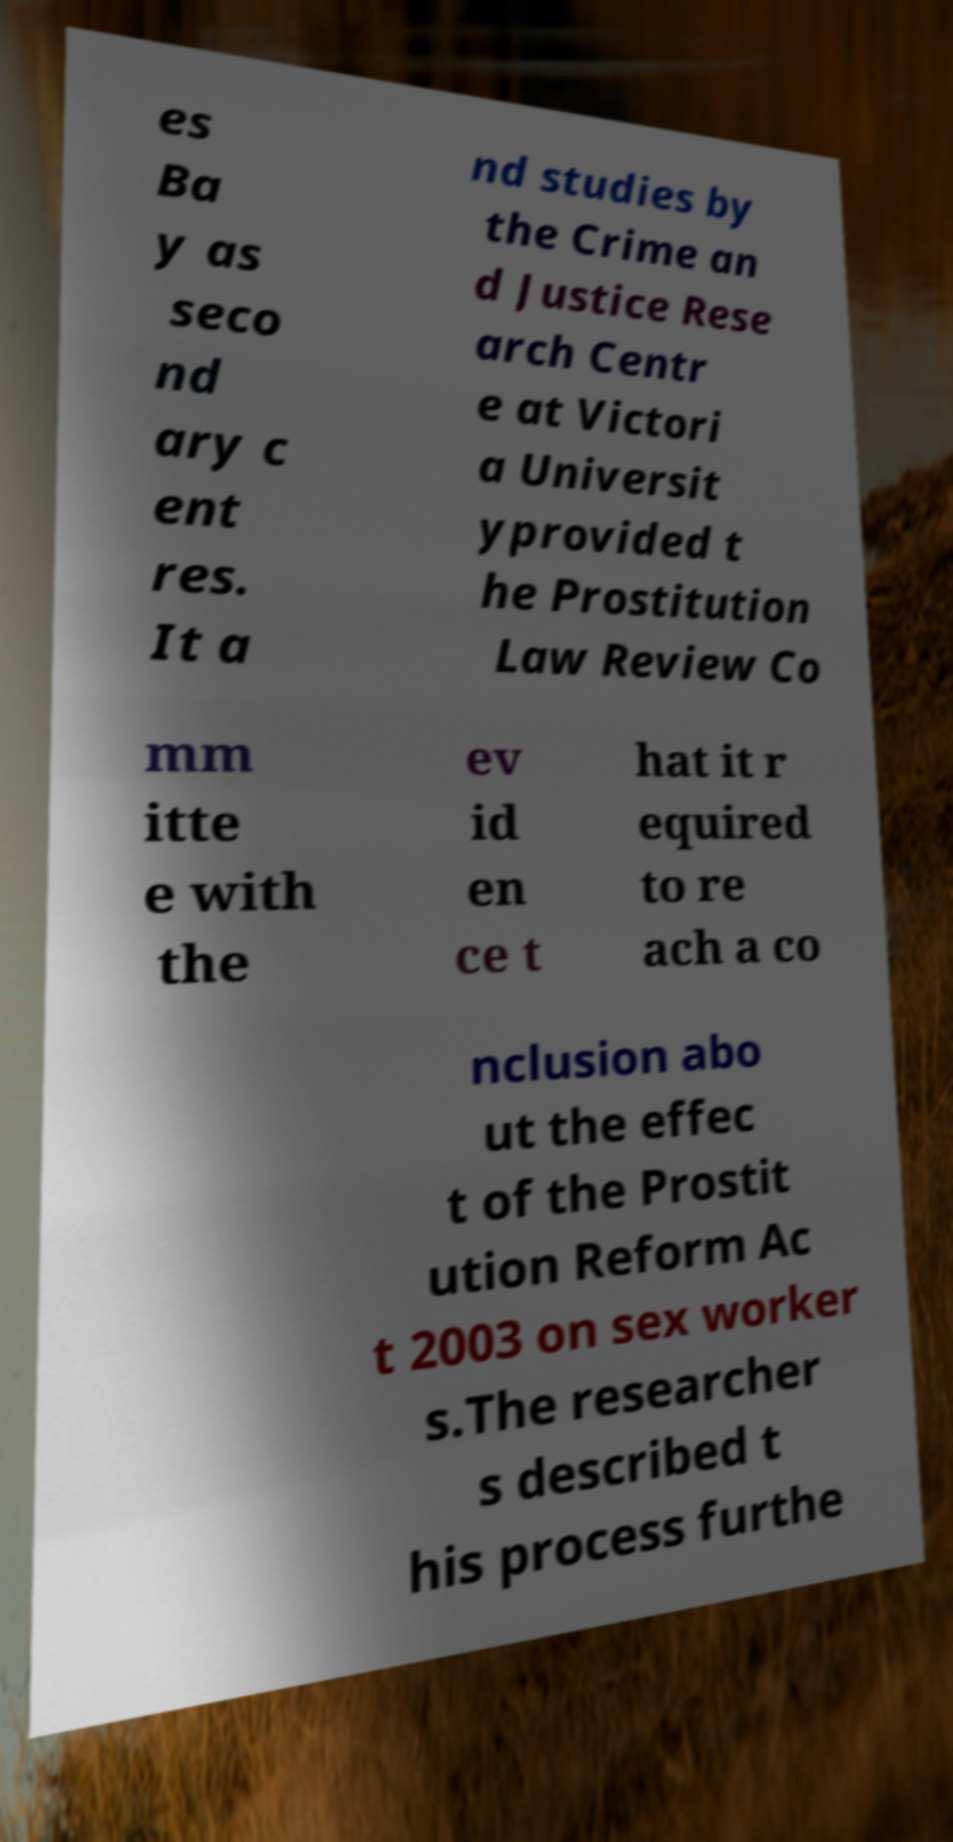Please identify and transcribe the text found in this image. es Ba y as seco nd ary c ent res. It a nd studies by the Crime an d Justice Rese arch Centr e at Victori a Universit yprovided t he Prostitution Law Review Co mm itte e with the ev id en ce t hat it r equired to re ach a co nclusion abo ut the effec t of the Prostit ution Reform Ac t 2003 on sex worker s.The researcher s described t his process furthe 